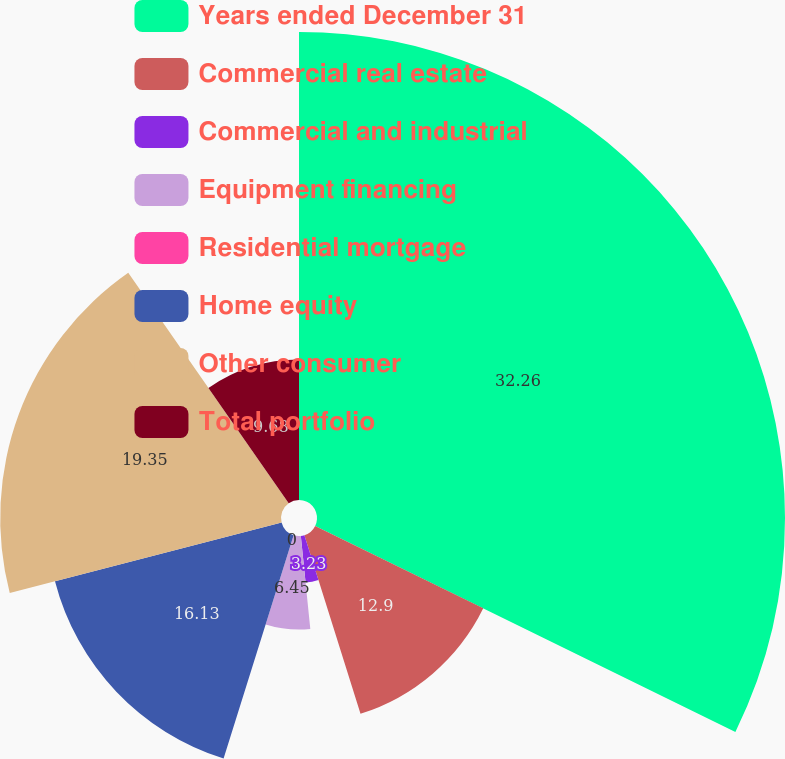Convert chart to OTSL. <chart><loc_0><loc_0><loc_500><loc_500><pie_chart><fcel>Years ended December 31<fcel>Commercial real estate<fcel>Commercial and industrial<fcel>Equipment financing<fcel>Residential mortgage<fcel>Home equity<fcel>Other consumer<fcel>Total portfolio<nl><fcel>32.25%<fcel>12.9%<fcel>3.23%<fcel>6.45%<fcel>0.0%<fcel>16.13%<fcel>19.35%<fcel>9.68%<nl></chart> 